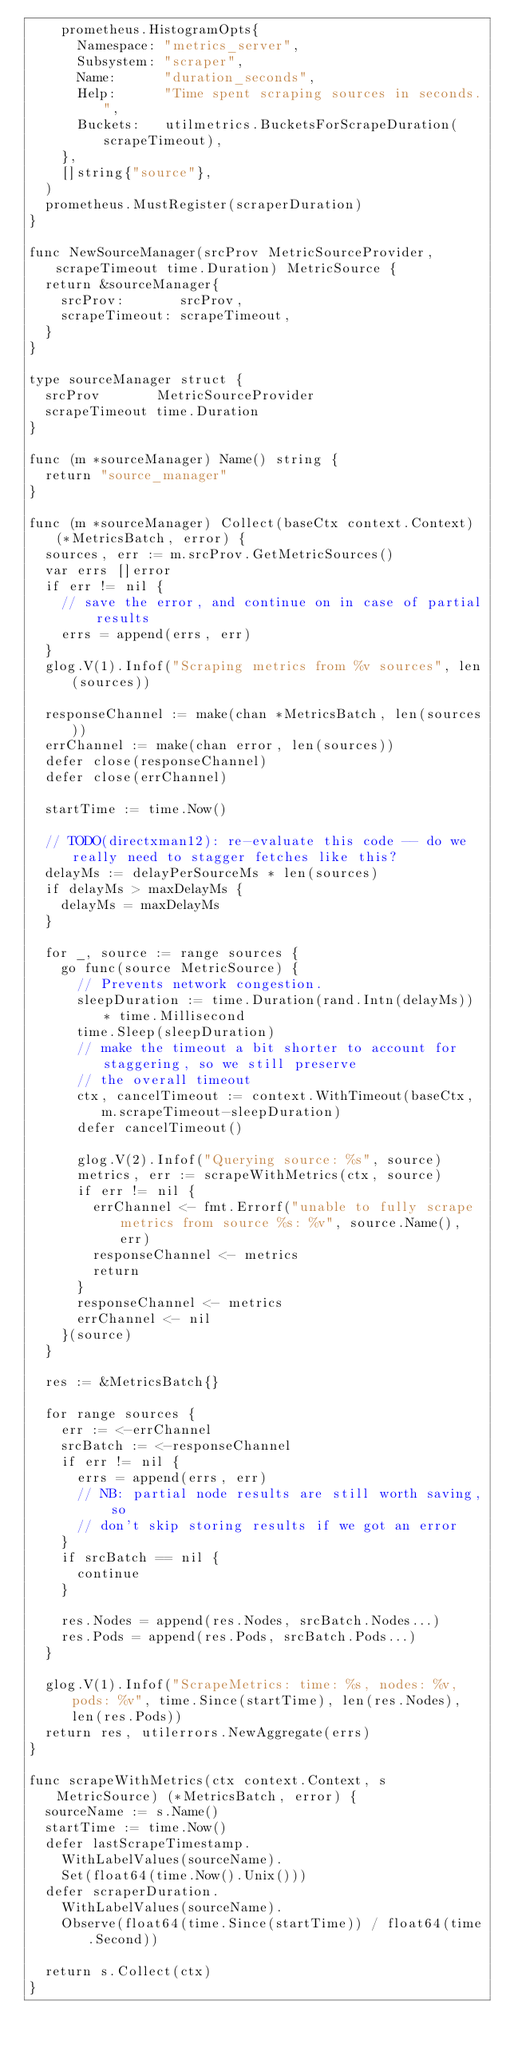Convert code to text. <code><loc_0><loc_0><loc_500><loc_500><_Go_>		prometheus.HistogramOpts{
			Namespace: "metrics_server",
			Subsystem: "scraper",
			Name:      "duration_seconds",
			Help:      "Time spent scraping sources in seconds.",
			Buckets:   utilmetrics.BucketsForScrapeDuration(scrapeTimeout),
		},
		[]string{"source"},
	)
	prometheus.MustRegister(scraperDuration)
}

func NewSourceManager(srcProv MetricSourceProvider, scrapeTimeout time.Duration) MetricSource {
	return &sourceManager{
		srcProv:       srcProv,
		scrapeTimeout: scrapeTimeout,
	}
}

type sourceManager struct {
	srcProv       MetricSourceProvider
	scrapeTimeout time.Duration
}

func (m *sourceManager) Name() string {
	return "source_manager"
}

func (m *sourceManager) Collect(baseCtx context.Context) (*MetricsBatch, error) {
	sources, err := m.srcProv.GetMetricSources()
	var errs []error
	if err != nil {
		// save the error, and continue on in case of partial results
		errs = append(errs, err)
	}
	glog.V(1).Infof("Scraping metrics from %v sources", len(sources))

	responseChannel := make(chan *MetricsBatch, len(sources))
	errChannel := make(chan error, len(sources))
	defer close(responseChannel)
	defer close(errChannel)

	startTime := time.Now()

	// TODO(directxman12): re-evaluate this code -- do we really need to stagger fetches like this?
	delayMs := delayPerSourceMs * len(sources)
	if delayMs > maxDelayMs {
		delayMs = maxDelayMs
	}

	for _, source := range sources {
		go func(source MetricSource) {
			// Prevents network congestion.
			sleepDuration := time.Duration(rand.Intn(delayMs)) * time.Millisecond
			time.Sleep(sleepDuration)
			// make the timeout a bit shorter to account for staggering, so we still preserve
			// the overall timeout
			ctx, cancelTimeout := context.WithTimeout(baseCtx, m.scrapeTimeout-sleepDuration)
			defer cancelTimeout()

			glog.V(2).Infof("Querying source: %s", source)
			metrics, err := scrapeWithMetrics(ctx, source)
			if err != nil {
				errChannel <- fmt.Errorf("unable to fully scrape metrics from source %s: %v", source.Name(), err)
				responseChannel <- metrics
				return
			}
			responseChannel <- metrics
			errChannel <- nil
		}(source)
	}

	res := &MetricsBatch{}

	for range sources {
		err := <-errChannel
		srcBatch := <-responseChannel
		if err != nil {
			errs = append(errs, err)
			// NB: partial node results are still worth saving, so
			// don't skip storing results if we got an error
		}
		if srcBatch == nil {
			continue
		}

		res.Nodes = append(res.Nodes, srcBatch.Nodes...)
		res.Pods = append(res.Pods, srcBatch.Pods...)
	}

	glog.V(1).Infof("ScrapeMetrics: time: %s, nodes: %v, pods: %v", time.Since(startTime), len(res.Nodes), len(res.Pods))
	return res, utilerrors.NewAggregate(errs)
}

func scrapeWithMetrics(ctx context.Context, s MetricSource) (*MetricsBatch, error) {
	sourceName := s.Name()
	startTime := time.Now()
	defer lastScrapeTimestamp.
		WithLabelValues(sourceName).
		Set(float64(time.Now().Unix()))
	defer scraperDuration.
		WithLabelValues(sourceName).
		Observe(float64(time.Since(startTime)) / float64(time.Second))

	return s.Collect(ctx)
}
</code> 